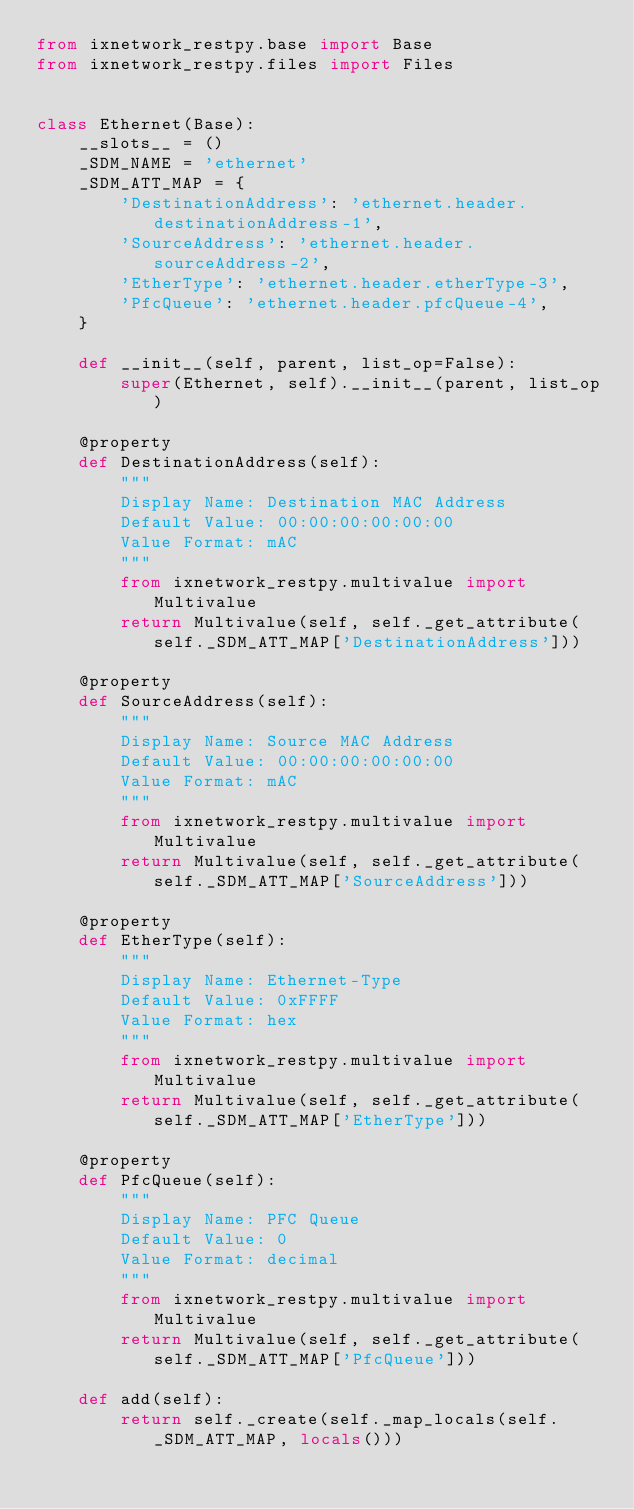<code> <loc_0><loc_0><loc_500><loc_500><_Python_>from ixnetwork_restpy.base import Base
from ixnetwork_restpy.files import Files


class Ethernet(Base):
    __slots__ = ()
    _SDM_NAME = 'ethernet'
    _SDM_ATT_MAP = {
        'DestinationAddress': 'ethernet.header.destinationAddress-1',
        'SourceAddress': 'ethernet.header.sourceAddress-2',
        'EtherType': 'ethernet.header.etherType-3',
        'PfcQueue': 'ethernet.header.pfcQueue-4',
    }

    def __init__(self, parent, list_op=False):
        super(Ethernet, self).__init__(parent, list_op)

    @property
    def DestinationAddress(self):
        """
        Display Name: Destination MAC Address
        Default Value: 00:00:00:00:00:00
        Value Format: mAC
        """
        from ixnetwork_restpy.multivalue import Multivalue
        return Multivalue(self, self._get_attribute(self._SDM_ATT_MAP['DestinationAddress']))

    @property
    def SourceAddress(self):
        """
        Display Name: Source MAC Address
        Default Value: 00:00:00:00:00:00
        Value Format: mAC
        """
        from ixnetwork_restpy.multivalue import Multivalue
        return Multivalue(self, self._get_attribute(self._SDM_ATT_MAP['SourceAddress']))

    @property
    def EtherType(self):
        """
        Display Name: Ethernet-Type
        Default Value: 0xFFFF
        Value Format: hex
        """
        from ixnetwork_restpy.multivalue import Multivalue
        return Multivalue(self, self._get_attribute(self._SDM_ATT_MAP['EtherType']))

    @property
    def PfcQueue(self):
        """
        Display Name: PFC Queue
        Default Value: 0
        Value Format: decimal
        """
        from ixnetwork_restpy.multivalue import Multivalue
        return Multivalue(self, self._get_attribute(self._SDM_ATT_MAP['PfcQueue']))

    def add(self):
        return self._create(self._map_locals(self._SDM_ATT_MAP, locals()))
</code> 